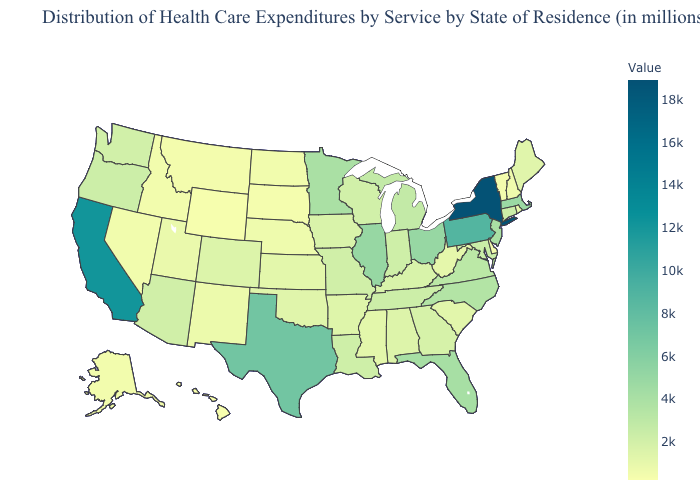Among the states that border Texas , does Louisiana have the highest value?
Short answer required. Yes. Does New York have the highest value in the USA?
Be succinct. Yes. Which states have the lowest value in the Northeast?
Be succinct. Vermont. Which states hav the highest value in the South?
Answer briefly. Texas. Does the map have missing data?
Short answer required. No. 